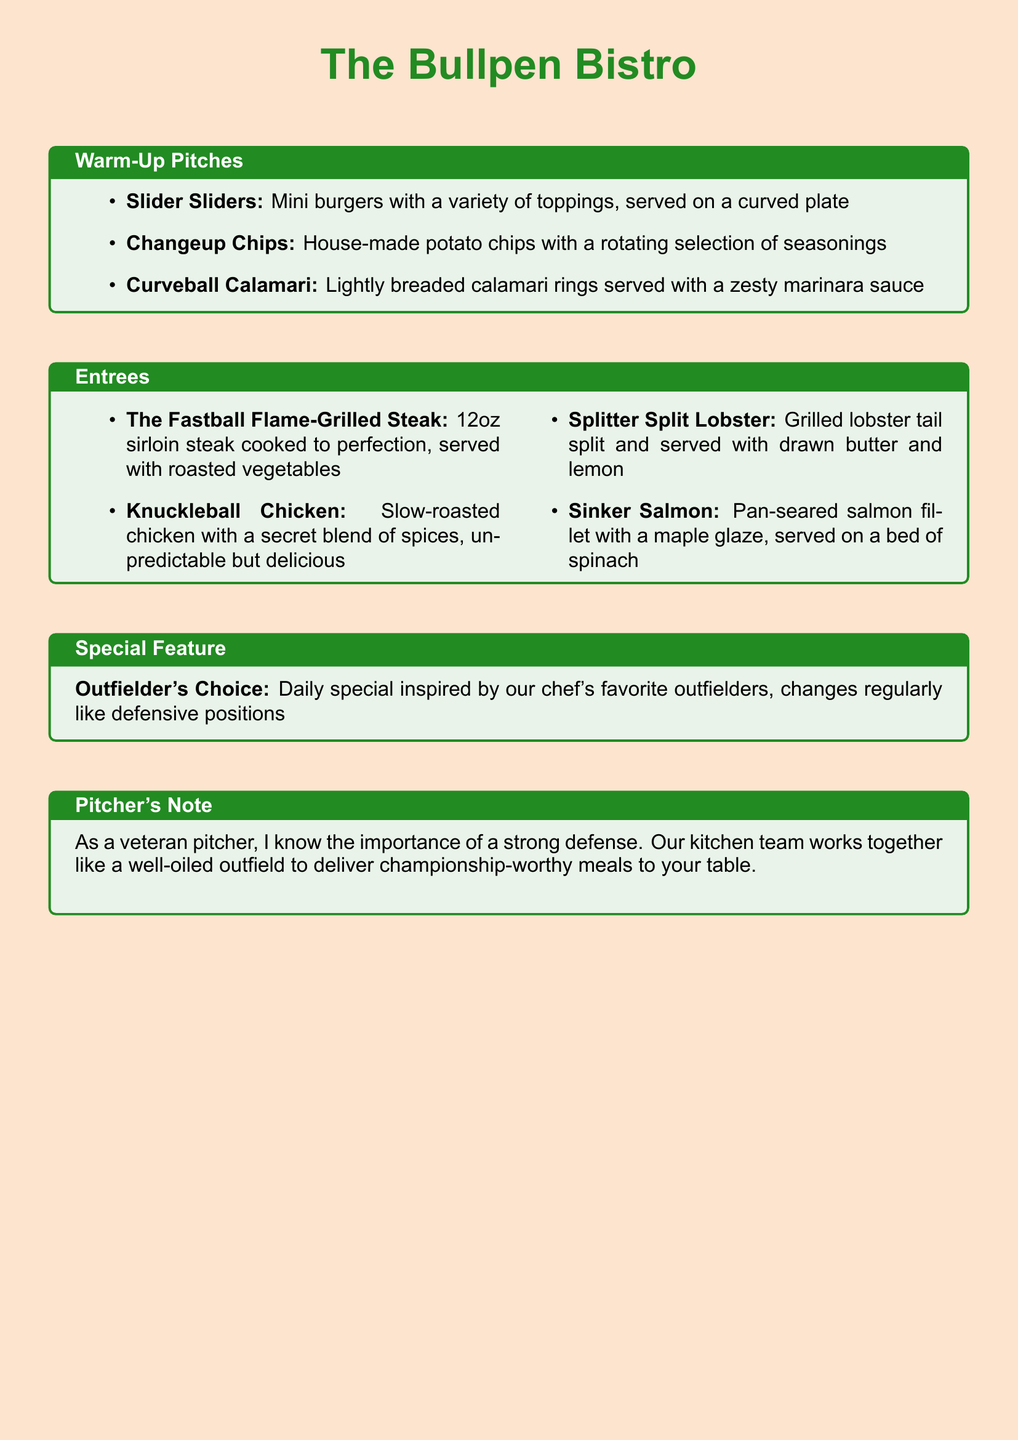What are the appetizers called? The appetizers section is titled "Warm-Up Pitches" in the document.
Answer: Warm-Up Pitches How many appetizers are listed? There are three items listed under the "Warm-Up Pitches" section in the document.
Answer: 3 What is the name of the steak entree? The steak entree is specifically called "The Fastball Flame-Grilled Steak" in the menu.
Answer: The Fastball Flame-Grilled Steak What type of dish is "Knuckleball Chicken"? This dish is described as a slow-roasted chicken with a secret blend of spices.
Answer: Slow-roasted chicken What is the daily special called? The daily special is referred to as "Outfielder's Choice" in the document.
Answer: Outfielder's Choice What is unique about "Sinker Salmon"? It is described as a pan-seared salmon fillet with a maple glaze, highlighting its preparation.
Answer: Maple glaze How many entree items are there? The menu lists a total of four entree items under the "Entrees" section.
Answer: 4 What does the "Pitcher's Note" emphasize? The "Pitcher's Note" emphasizes the teamwork in the kitchen similar to a strong defense in baseball.
Answer: Strong defense What is served with the "Splitter Split Lobster"? The dish comes with drawn butter and lemon as accompaniments.
Answer: Drawn butter and lemon 